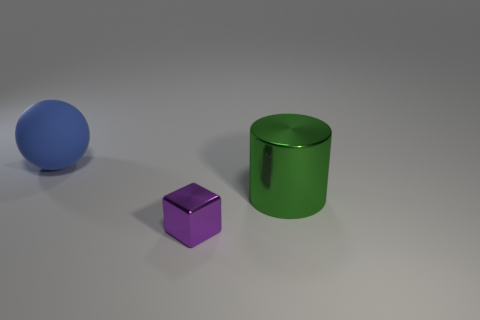Add 1 blue matte balls. How many objects exist? 4 Subtract all spheres. How many objects are left? 2 Add 2 purple metal objects. How many purple metal objects are left? 3 Add 3 big green metallic spheres. How many big green metallic spheres exist? 3 Subtract 1 blue spheres. How many objects are left? 2 Subtract 1 cubes. How many cubes are left? 0 Subtract all cyan balls. Subtract all brown cubes. How many balls are left? 1 Subtract all large green rubber blocks. Subtract all big green shiny objects. How many objects are left? 2 